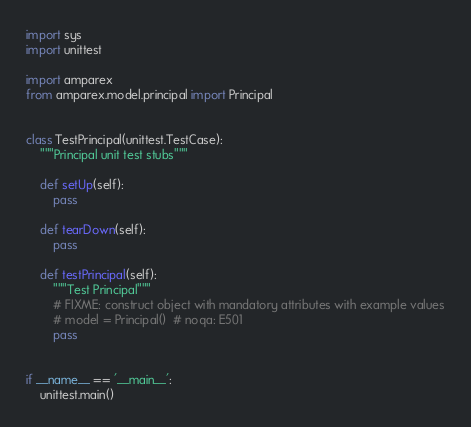<code> <loc_0><loc_0><loc_500><loc_500><_Python_>
import sys
import unittest

import amparex
from amparex.model.principal import Principal


class TestPrincipal(unittest.TestCase):
    """Principal unit test stubs"""

    def setUp(self):
        pass

    def tearDown(self):
        pass

    def testPrincipal(self):
        """Test Principal"""
        # FIXME: construct object with mandatory attributes with example values
        # model = Principal()  # noqa: E501
        pass


if __name__ == '__main__':
    unittest.main()
</code> 